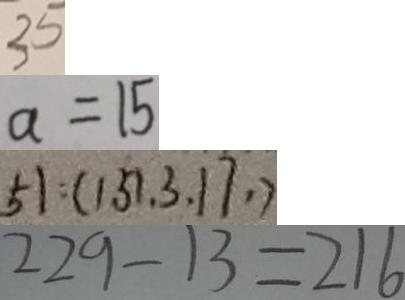<formula> <loc_0><loc_0><loc_500><loc_500>3 5 
 a = 1 5 
 5 1 : ( 1 5 1 , 3 , 1 7 , ) 
 2 2 9 - 1 3 = 2 1 6</formula> 